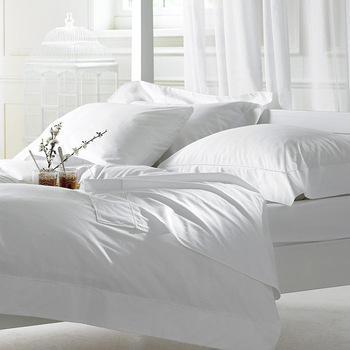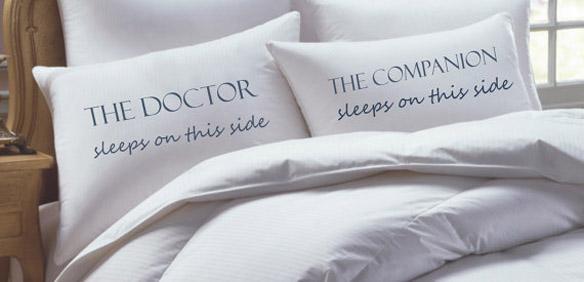The first image is the image on the left, the second image is the image on the right. Assess this claim about the two images: "Pillows in both of the images have words written on them.". Correct or not? Answer yes or no. No. The first image is the image on the left, the second image is the image on the right. Considering the images on both sides, is "The right image shows a bed with a white comforter and side-by-side white pillows printed with non-cursive dark letters, propped atop plain white pillows." valid? Answer yes or no. Yes. 